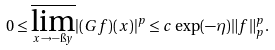Convert formula to latex. <formula><loc_0><loc_0><loc_500><loc_500>0 \leq \underset { x \to - \i y } \varlimsup | ( G f ) ( x ) | ^ { p } \leq c \exp ( - \eta ) \| f \| _ { p } ^ { p } .</formula> 